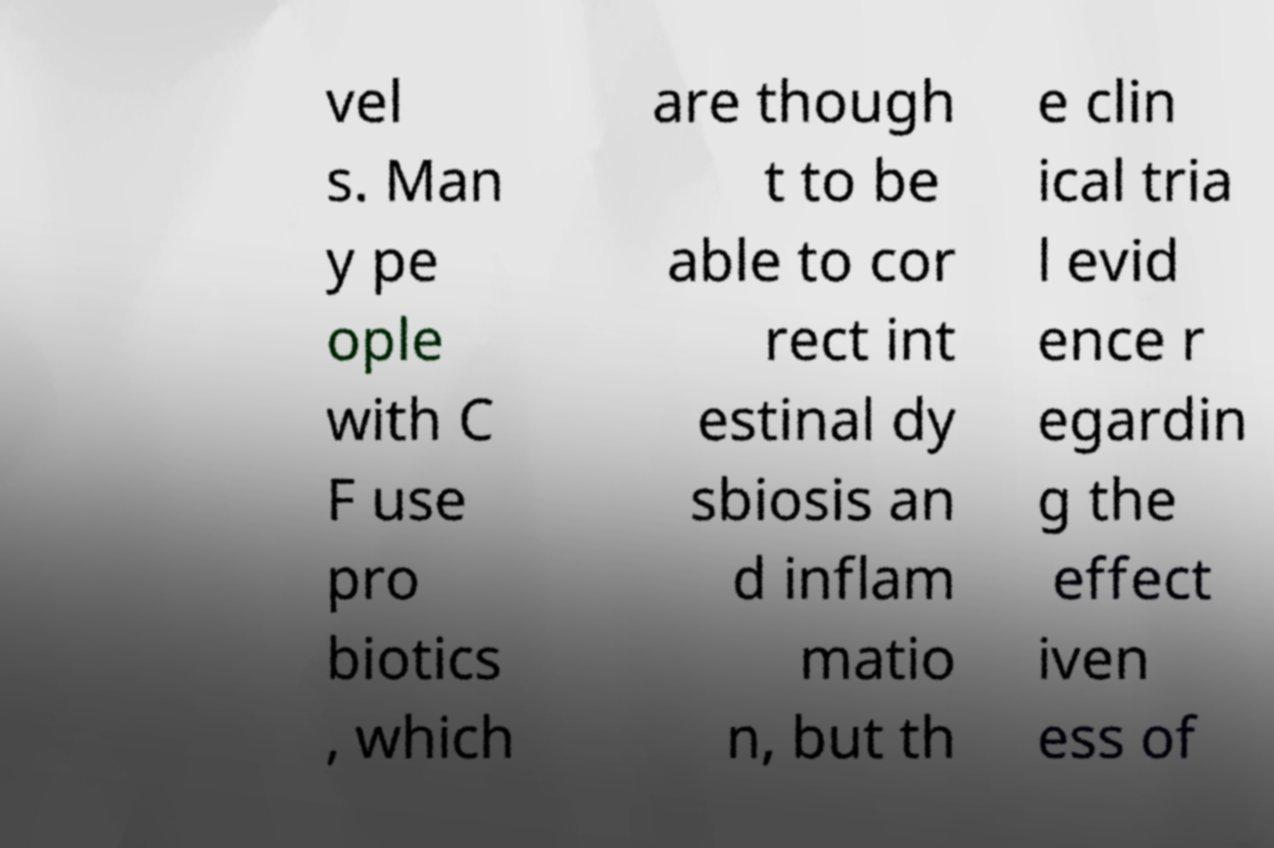Can you read and provide the text displayed in the image?This photo seems to have some interesting text. Can you extract and type it out for me? vel s. Man y pe ople with C F use pro biotics , which are though t to be able to cor rect int estinal dy sbiosis an d inflam matio n, but th e clin ical tria l evid ence r egardin g the effect iven ess of 